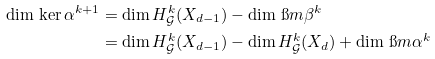<formula> <loc_0><loc_0><loc_500><loc_500>\dim \, \ker \alpha ^ { k + 1 } & = \dim H _ { \mathcal { G } } ^ { k } ( X _ { d - 1 } ) - \dim \, \i m \beta ^ { k } \\ & = \dim H _ { \mathcal { G } } ^ { k } ( X _ { d - 1 } ) - \dim H _ { \mathcal { G } } ^ { k } ( X _ { d } ) + \dim \, \i m \alpha ^ { k }</formula> 